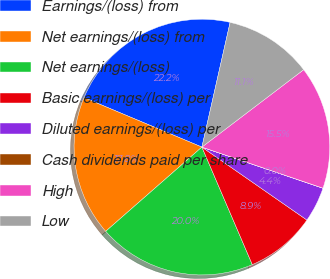Convert chart. <chart><loc_0><loc_0><loc_500><loc_500><pie_chart><fcel>Earnings/(loss) from<fcel>Net earnings/(loss) from<fcel>Net earnings/(loss)<fcel>Basic earnings/(loss) per<fcel>Diluted earnings/(loss) per<fcel>Cash dividends paid per share<fcel>High<fcel>Low<nl><fcel>22.22%<fcel>17.77%<fcel>20.0%<fcel>8.89%<fcel>4.45%<fcel>0.01%<fcel>15.55%<fcel>11.11%<nl></chart> 